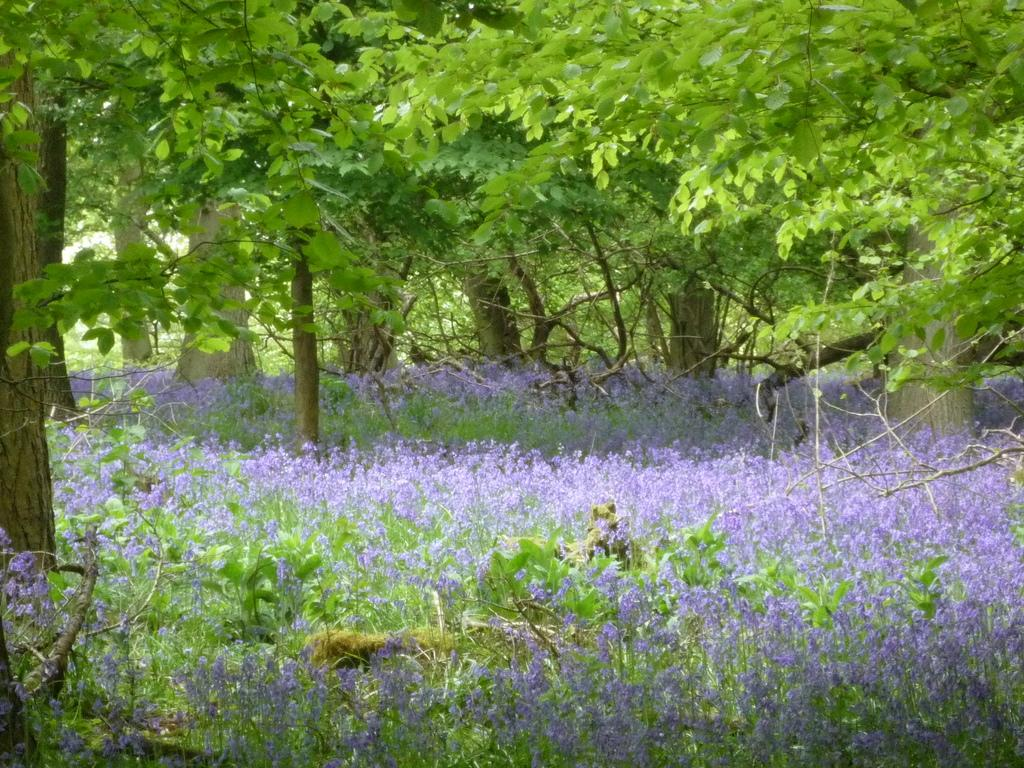What type of plants can be seen in the image? There are flowers in the image. What color are the flowers? The flowers are purple. What else can be seen in the image besides the flowers? There are trees in the image. What type of music can be heard coming from the babies in the image? There are no babies present in the image, so it's not possible to determine what, if any, music might be heard. 